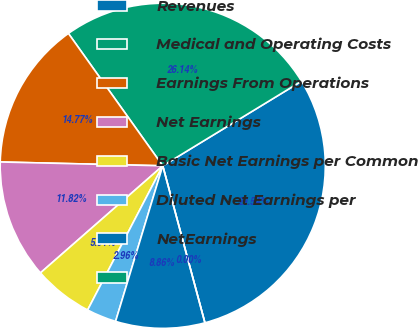Convert chart to OTSL. <chart><loc_0><loc_0><loc_500><loc_500><pie_chart><fcel>Revenues<fcel>Medical and Operating Costs<fcel>Earnings From Operations<fcel>Net Earnings<fcel>Basic Net Earnings per Common<fcel>Diluted Net Earnings per<fcel>NetEarnings<fcel>Unnamed: 7<nl><fcel>29.54%<fcel>26.14%<fcel>14.77%<fcel>11.82%<fcel>5.91%<fcel>2.96%<fcel>8.86%<fcel>0.0%<nl></chart> 